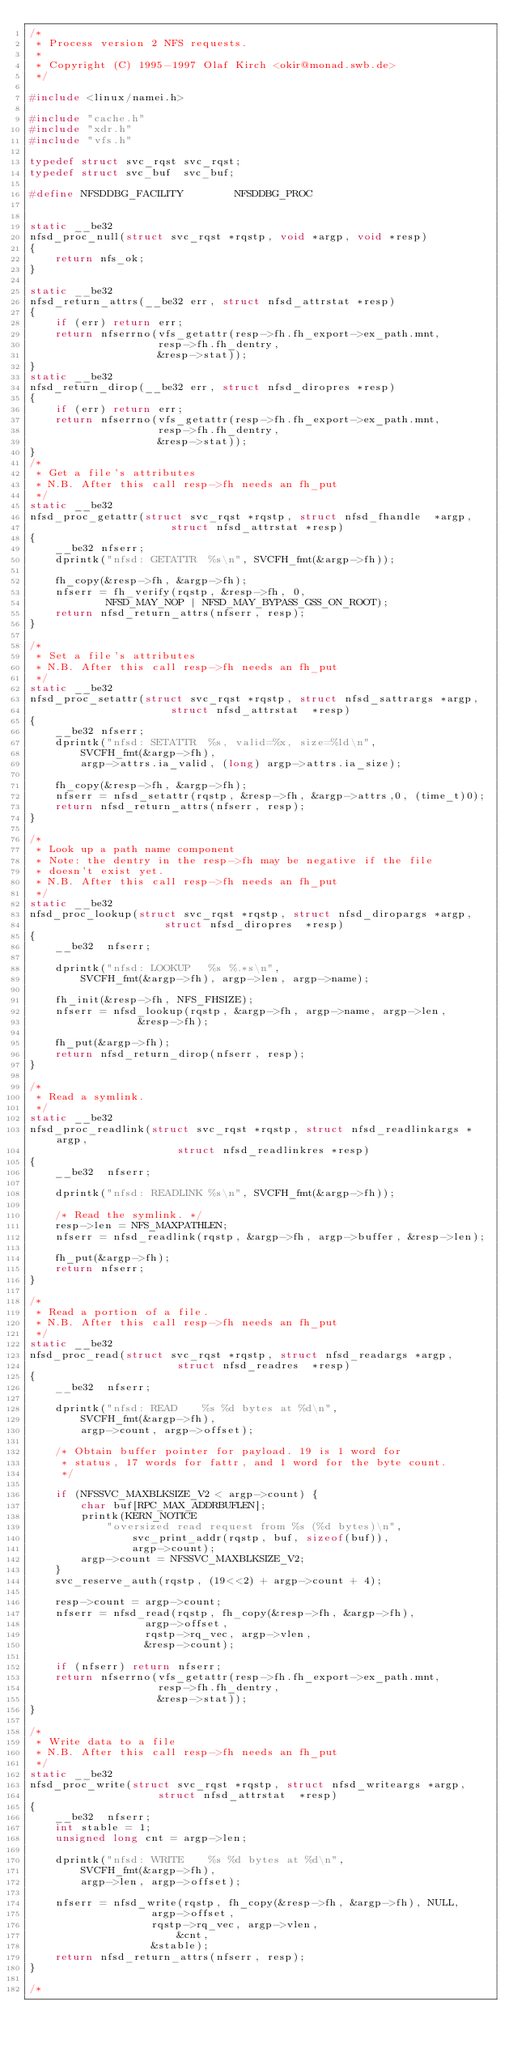<code> <loc_0><loc_0><loc_500><loc_500><_C_>/*
 * Process version 2 NFS requests.
 *
 * Copyright (C) 1995-1997 Olaf Kirch <okir@monad.swb.de>
 */

#include <linux/namei.h>

#include "cache.h"
#include "xdr.h"
#include "vfs.h"

typedef struct svc_rqst	svc_rqst;
typedef struct svc_buf	svc_buf;

#define NFSDDBG_FACILITY		NFSDDBG_PROC


static __be32
nfsd_proc_null(struct svc_rqst *rqstp, void *argp, void *resp)
{
	return nfs_ok;
}

static __be32
nfsd_return_attrs(__be32 err, struct nfsd_attrstat *resp)
{
	if (err) return err;
	return nfserrno(vfs_getattr(resp->fh.fh_export->ex_path.mnt,
				    resp->fh.fh_dentry,
				    &resp->stat));
}
static __be32
nfsd_return_dirop(__be32 err, struct nfsd_diropres *resp)
{
	if (err) return err;
	return nfserrno(vfs_getattr(resp->fh.fh_export->ex_path.mnt,
				    resp->fh.fh_dentry,
				    &resp->stat));
}
/*
 * Get a file's attributes
 * N.B. After this call resp->fh needs an fh_put
 */
static __be32
nfsd_proc_getattr(struct svc_rqst *rqstp, struct nfsd_fhandle  *argp,
					  struct nfsd_attrstat *resp)
{
	__be32 nfserr;
	dprintk("nfsd: GETATTR  %s\n", SVCFH_fmt(&argp->fh));

	fh_copy(&resp->fh, &argp->fh);
	nfserr = fh_verify(rqstp, &resp->fh, 0,
			NFSD_MAY_NOP | NFSD_MAY_BYPASS_GSS_ON_ROOT);
	return nfsd_return_attrs(nfserr, resp);
}

/*
 * Set a file's attributes
 * N.B. After this call resp->fh needs an fh_put
 */
static __be32
nfsd_proc_setattr(struct svc_rqst *rqstp, struct nfsd_sattrargs *argp,
					  struct nfsd_attrstat  *resp)
{
	__be32 nfserr;
	dprintk("nfsd: SETATTR  %s, valid=%x, size=%ld\n",
		SVCFH_fmt(&argp->fh),
		argp->attrs.ia_valid, (long) argp->attrs.ia_size);

	fh_copy(&resp->fh, &argp->fh);
	nfserr = nfsd_setattr(rqstp, &resp->fh, &argp->attrs,0, (time_t)0);
	return nfsd_return_attrs(nfserr, resp);
}

/*
 * Look up a path name component
 * Note: the dentry in the resp->fh may be negative if the file
 * doesn't exist yet.
 * N.B. After this call resp->fh needs an fh_put
 */
static __be32
nfsd_proc_lookup(struct svc_rqst *rqstp, struct nfsd_diropargs *argp,
					 struct nfsd_diropres  *resp)
{
	__be32	nfserr;

	dprintk("nfsd: LOOKUP   %s %.*s\n",
		SVCFH_fmt(&argp->fh), argp->len, argp->name);

	fh_init(&resp->fh, NFS_FHSIZE);
	nfserr = nfsd_lookup(rqstp, &argp->fh, argp->name, argp->len,
				 &resp->fh);

	fh_put(&argp->fh);
	return nfsd_return_dirop(nfserr, resp);
}

/*
 * Read a symlink.
 */
static __be32
nfsd_proc_readlink(struct svc_rqst *rqstp, struct nfsd_readlinkargs *argp,
					   struct nfsd_readlinkres *resp)
{
	__be32	nfserr;

	dprintk("nfsd: READLINK %s\n", SVCFH_fmt(&argp->fh));

	/* Read the symlink. */
	resp->len = NFS_MAXPATHLEN;
	nfserr = nfsd_readlink(rqstp, &argp->fh, argp->buffer, &resp->len);

	fh_put(&argp->fh);
	return nfserr;
}

/*
 * Read a portion of a file.
 * N.B. After this call resp->fh needs an fh_put
 */
static __be32
nfsd_proc_read(struct svc_rqst *rqstp, struct nfsd_readargs *argp,
				       struct nfsd_readres  *resp)
{
	__be32	nfserr;

	dprintk("nfsd: READ    %s %d bytes at %d\n",
		SVCFH_fmt(&argp->fh),
		argp->count, argp->offset);

	/* Obtain buffer pointer for payload. 19 is 1 word for
	 * status, 17 words for fattr, and 1 word for the byte count.
	 */

	if (NFSSVC_MAXBLKSIZE_V2 < argp->count) {
		char buf[RPC_MAX_ADDRBUFLEN];
		printk(KERN_NOTICE
			"oversized read request from %s (%d bytes)\n",
				svc_print_addr(rqstp, buf, sizeof(buf)),
				argp->count);
		argp->count = NFSSVC_MAXBLKSIZE_V2;
	}
	svc_reserve_auth(rqstp, (19<<2) + argp->count + 4);

	resp->count = argp->count;
	nfserr = nfsd_read(rqstp, fh_copy(&resp->fh, &argp->fh),
				  argp->offset,
			   	  rqstp->rq_vec, argp->vlen,
				  &resp->count);

	if (nfserr) return nfserr;
	return nfserrno(vfs_getattr(resp->fh.fh_export->ex_path.mnt,
				    resp->fh.fh_dentry,
				    &resp->stat));
}

/*
 * Write data to a file
 * N.B. After this call resp->fh needs an fh_put
 */
static __be32
nfsd_proc_write(struct svc_rqst *rqstp, struct nfsd_writeargs *argp,
					struct nfsd_attrstat  *resp)
{
	__be32	nfserr;
	int	stable = 1;
	unsigned long cnt = argp->len;

	dprintk("nfsd: WRITE    %s %d bytes at %d\n",
		SVCFH_fmt(&argp->fh),
		argp->len, argp->offset);

	nfserr = nfsd_write(rqstp, fh_copy(&resp->fh, &argp->fh), NULL,
				   argp->offset,
				   rqstp->rq_vec, argp->vlen,
			           &cnt,
				   &stable);
	return nfsd_return_attrs(nfserr, resp);
}

/*</code> 